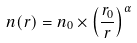Convert formula to latex. <formula><loc_0><loc_0><loc_500><loc_500>n ( r ) = n _ { 0 } \times \left ( \frac { r _ { 0 } } { r } \right ) ^ { \alpha }</formula> 